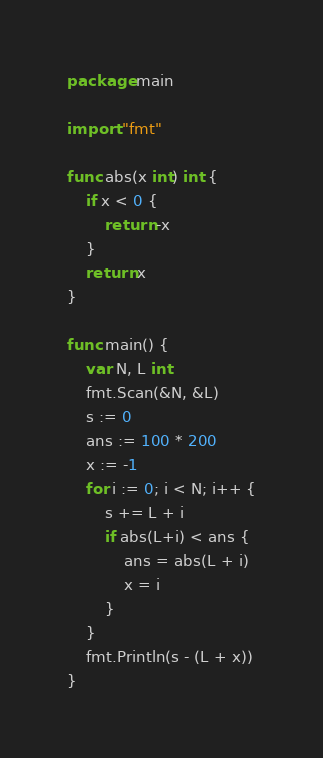Convert code to text. <code><loc_0><loc_0><loc_500><loc_500><_Go_>package main

import "fmt"

func abs(x int) int {
	if x < 0 {
		return -x
	}
	return x
}

func main() {
	var N, L int
	fmt.Scan(&N, &L)
	s := 0
	ans := 100 * 200
	x := -1
	for i := 0; i < N; i++ {
		s += L + i
		if abs(L+i) < ans {
			ans = abs(L + i)
			x = i
		}
	}
	fmt.Println(s - (L + x))
}
</code> 